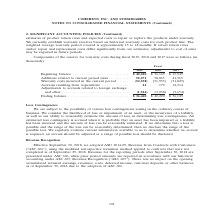According to Coherent's financial document, What is the approximate weighted average warranty period covered? approximately 15 to 18 months. The document states: ". The weighted average warranty period covered is approximately 15 to 18 months. If actual return rates and/or repair and replacement costs differ sig..." Also, What does the determination of such reserves require the company to make? Based on the financial document, the answer is make estimates of product return rates and expected costs to repair or replace the products under warranty. We currently establish warranty reserves based on historical warranty costs for each product line. Also, In which years was the reserve for warranty costs provided in the table? The document contains multiple relevant values: 2019, 2018, 2017. From the document: "Fiscal 2019 2018 2017 Fiscal 2019 2018 2017 Fiscal 2019 2018 2017..." Additionally, In which year was the Ending balance the largest? According to the financial document, 2018. The relevant text states: "Fiscal 2019 2018 2017..." Also, can you calculate: What was the change in Beginning balance in 2019 from 2018? Based on the calculation: 40,220-36,149, the result is 4071 (in thousands). This is based on the information: "Beginning balance . $ 40,220 $ 36,149 $ 15,949 Additions related to current period sales . 52,271 58,865 41,365 Warranty costs i Beginning balance . $ 40,220 $ 36,149 $ 15,949 Additions related to cur..." The key data points involved are: 36,149, 40,220. Also, can you calculate: What was the percentage change in Beginning balance in 2019 from 2018? To answer this question, I need to perform calculations using the financial data. The calculation is: (40,220-36,149)/36,149, which equals 11.26 (percentage). This is based on the information: "Beginning balance . $ 40,220 $ 36,149 $ 15,949 Additions related to current period sales . 52,271 58,865 41,365 Warranty costs i Beginning balance . $ 40,220 $ 36,149 $ 15,949 Additions related to cur..." The key data points involved are: 36,149, 40,220. 